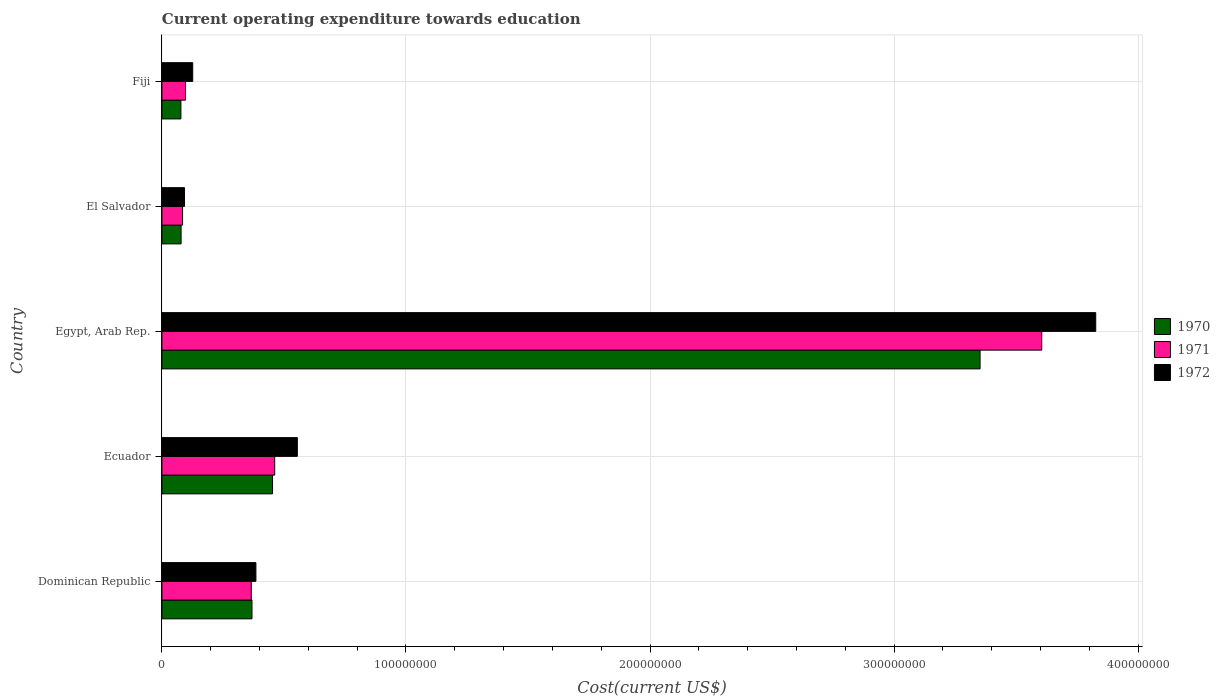What is the label of the 4th group of bars from the top?
Offer a very short reply. Ecuador. What is the expenditure towards education in 1972 in Egypt, Arab Rep.?
Offer a very short reply. 3.83e+08. Across all countries, what is the maximum expenditure towards education in 1970?
Your answer should be very brief. 3.35e+08. Across all countries, what is the minimum expenditure towards education in 1970?
Your response must be concise. 7.79e+06. In which country was the expenditure towards education in 1972 maximum?
Offer a terse response. Egypt, Arab Rep. In which country was the expenditure towards education in 1972 minimum?
Your answer should be very brief. El Salvador. What is the total expenditure towards education in 1971 in the graph?
Provide a short and direct response. 4.61e+08. What is the difference between the expenditure towards education in 1970 in Ecuador and that in Fiji?
Give a very brief answer. 3.75e+07. What is the difference between the expenditure towards education in 1972 in El Salvador and the expenditure towards education in 1971 in Egypt, Arab Rep.?
Your response must be concise. -3.51e+08. What is the average expenditure towards education in 1970 per country?
Provide a succinct answer. 8.66e+07. What is the difference between the expenditure towards education in 1971 and expenditure towards education in 1970 in Dominican Republic?
Provide a short and direct response. -2.90e+05. What is the ratio of the expenditure towards education in 1970 in Egypt, Arab Rep. to that in Fiji?
Offer a terse response. 43.04. Is the difference between the expenditure towards education in 1971 in Ecuador and Fiji greater than the difference between the expenditure towards education in 1970 in Ecuador and Fiji?
Keep it short and to the point. No. What is the difference between the highest and the second highest expenditure towards education in 1972?
Give a very brief answer. 3.27e+08. What is the difference between the highest and the lowest expenditure towards education in 1971?
Provide a succinct answer. 3.52e+08. What does the 2nd bar from the top in Dominican Republic represents?
Give a very brief answer. 1971. What does the 3rd bar from the bottom in El Salvador represents?
Keep it short and to the point. 1972. Is it the case that in every country, the sum of the expenditure towards education in 1971 and expenditure towards education in 1972 is greater than the expenditure towards education in 1970?
Offer a terse response. Yes. Are all the bars in the graph horizontal?
Give a very brief answer. Yes. How many countries are there in the graph?
Offer a very short reply. 5. What is the difference between two consecutive major ticks on the X-axis?
Make the answer very short. 1.00e+08. Does the graph contain any zero values?
Offer a very short reply. No. Where does the legend appear in the graph?
Offer a terse response. Center right. What is the title of the graph?
Provide a succinct answer. Current operating expenditure towards education. What is the label or title of the X-axis?
Ensure brevity in your answer.  Cost(current US$). What is the label or title of the Y-axis?
Provide a short and direct response. Country. What is the Cost(current US$) of 1970 in Dominican Republic?
Ensure brevity in your answer.  3.69e+07. What is the Cost(current US$) in 1971 in Dominican Republic?
Ensure brevity in your answer.  3.66e+07. What is the Cost(current US$) of 1972 in Dominican Republic?
Keep it short and to the point. 3.85e+07. What is the Cost(current US$) in 1970 in Ecuador?
Provide a short and direct response. 4.53e+07. What is the Cost(current US$) in 1971 in Ecuador?
Provide a succinct answer. 4.62e+07. What is the Cost(current US$) in 1972 in Ecuador?
Provide a short and direct response. 5.55e+07. What is the Cost(current US$) of 1970 in Egypt, Arab Rep.?
Offer a very short reply. 3.35e+08. What is the Cost(current US$) in 1971 in Egypt, Arab Rep.?
Offer a very short reply. 3.60e+08. What is the Cost(current US$) in 1972 in Egypt, Arab Rep.?
Your response must be concise. 3.83e+08. What is the Cost(current US$) in 1970 in El Salvador?
Give a very brief answer. 7.86e+06. What is the Cost(current US$) in 1971 in El Salvador?
Ensure brevity in your answer.  8.46e+06. What is the Cost(current US$) in 1972 in El Salvador?
Provide a short and direct response. 9.26e+06. What is the Cost(current US$) of 1970 in Fiji?
Give a very brief answer. 7.79e+06. What is the Cost(current US$) of 1971 in Fiji?
Your response must be concise. 9.67e+06. What is the Cost(current US$) of 1972 in Fiji?
Your answer should be compact. 1.26e+07. Across all countries, what is the maximum Cost(current US$) of 1970?
Keep it short and to the point. 3.35e+08. Across all countries, what is the maximum Cost(current US$) of 1971?
Your answer should be compact. 3.60e+08. Across all countries, what is the maximum Cost(current US$) in 1972?
Offer a very short reply. 3.83e+08. Across all countries, what is the minimum Cost(current US$) of 1970?
Offer a terse response. 7.79e+06. Across all countries, what is the minimum Cost(current US$) in 1971?
Give a very brief answer. 8.46e+06. Across all countries, what is the minimum Cost(current US$) in 1972?
Provide a short and direct response. 9.26e+06. What is the total Cost(current US$) of 1970 in the graph?
Keep it short and to the point. 4.33e+08. What is the total Cost(current US$) of 1971 in the graph?
Offer a terse response. 4.61e+08. What is the total Cost(current US$) in 1972 in the graph?
Your answer should be very brief. 4.98e+08. What is the difference between the Cost(current US$) of 1970 in Dominican Republic and that in Ecuador?
Your answer should be very brief. -8.43e+06. What is the difference between the Cost(current US$) in 1971 in Dominican Republic and that in Ecuador?
Make the answer very short. -9.60e+06. What is the difference between the Cost(current US$) of 1972 in Dominican Republic and that in Ecuador?
Make the answer very short. -1.70e+07. What is the difference between the Cost(current US$) of 1970 in Dominican Republic and that in Egypt, Arab Rep.?
Keep it short and to the point. -2.98e+08. What is the difference between the Cost(current US$) in 1971 in Dominican Republic and that in Egypt, Arab Rep.?
Give a very brief answer. -3.24e+08. What is the difference between the Cost(current US$) of 1972 in Dominican Republic and that in Egypt, Arab Rep.?
Provide a succinct answer. -3.44e+08. What is the difference between the Cost(current US$) of 1970 in Dominican Republic and that in El Salvador?
Offer a very short reply. 2.90e+07. What is the difference between the Cost(current US$) of 1971 in Dominican Republic and that in El Salvador?
Keep it short and to the point. 2.82e+07. What is the difference between the Cost(current US$) of 1972 in Dominican Republic and that in El Salvador?
Give a very brief answer. 2.93e+07. What is the difference between the Cost(current US$) in 1970 in Dominican Republic and that in Fiji?
Provide a short and direct response. 2.91e+07. What is the difference between the Cost(current US$) of 1971 in Dominican Republic and that in Fiji?
Your answer should be compact. 2.69e+07. What is the difference between the Cost(current US$) of 1972 in Dominican Republic and that in Fiji?
Your answer should be compact. 2.59e+07. What is the difference between the Cost(current US$) in 1970 in Ecuador and that in Egypt, Arab Rep.?
Give a very brief answer. -2.90e+08. What is the difference between the Cost(current US$) in 1971 in Ecuador and that in Egypt, Arab Rep.?
Your answer should be very brief. -3.14e+08. What is the difference between the Cost(current US$) of 1972 in Ecuador and that in Egypt, Arab Rep.?
Provide a succinct answer. -3.27e+08. What is the difference between the Cost(current US$) of 1970 in Ecuador and that in El Salvador?
Give a very brief answer. 3.75e+07. What is the difference between the Cost(current US$) in 1971 in Ecuador and that in El Salvador?
Provide a succinct answer. 3.78e+07. What is the difference between the Cost(current US$) in 1972 in Ecuador and that in El Salvador?
Ensure brevity in your answer.  4.62e+07. What is the difference between the Cost(current US$) in 1970 in Ecuador and that in Fiji?
Your response must be concise. 3.75e+07. What is the difference between the Cost(current US$) in 1971 in Ecuador and that in Fiji?
Offer a very short reply. 3.65e+07. What is the difference between the Cost(current US$) of 1972 in Ecuador and that in Fiji?
Your answer should be compact. 4.29e+07. What is the difference between the Cost(current US$) in 1970 in Egypt, Arab Rep. and that in El Salvador?
Your answer should be compact. 3.27e+08. What is the difference between the Cost(current US$) of 1971 in Egypt, Arab Rep. and that in El Salvador?
Make the answer very short. 3.52e+08. What is the difference between the Cost(current US$) in 1972 in Egypt, Arab Rep. and that in El Salvador?
Ensure brevity in your answer.  3.73e+08. What is the difference between the Cost(current US$) of 1970 in Egypt, Arab Rep. and that in Fiji?
Give a very brief answer. 3.27e+08. What is the difference between the Cost(current US$) in 1971 in Egypt, Arab Rep. and that in Fiji?
Your answer should be compact. 3.51e+08. What is the difference between the Cost(current US$) in 1972 in Egypt, Arab Rep. and that in Fiji?
Ensure brevity in your answer.  3.70e+08. What is the difference between the Cost(current US$) in 1970 in El Salvador and that in Fiji?
Make the answer very short. 7.56e+04. What is the difference between the Cost(current US$) of 1971 in El Salvador and that in Fiji?
Provide a short and direct response. -1.21e+06. What is the difference between the Cost(current US$) of 1972 in El Salvador and that in Fiji?
Ensure brevity in your answer.  -3.37e+06. What is the difference between the Cost(current US$) in 1970 in Dominican Republic and the Cost(current US$) in 1971 in Ecuador?
Your answer should be very brief. -9.31e+06. What is the difference between the Cost(current US$) of 1970 in Dominican Republic and the Cost(current US$) of 1972 in Ecuador?
Provide a succinct answer. -1.86e+07. What is the difference between the Cost(current US$) of 1971 in Dominican Republic and the Cost(current US$) of 1972 in Ecuador?
Make the answer very short. -1.89e+07. What is the difference between the Cost(current US$) of 1970 in Dominican Republic and the Cost(current US$) of 1971 in Egypt, Arab Rep.?
Your answer should be compact. -3.24e+08. What is the difference between the Cost(current US$) of 1970 in Dominican Republic and the Cost(current US$) of 1972 in Egypt, Arab Rep.?
Give a very brief answer. -3.46e+08. What is the difference between the Cost(current US$) in 1971 in Dominican Republic and the Cost(current US$) in 1972 in Egypt, Arab Rep.?
Give a very brief answer. -3.46e+08. What is the difference between the Cost(current US$) in 1970 in Dominican Republic and the Cost(current US$) in 1971 in El Salvador?
Offer a terse response. 2.84e+07. What is the difference between the Cost(current US$) in 1970 in Dominican Republic and the Cost(current US$) in 1972 in El Salvador?
Keep it short and to the point. 2.76e+07. What is the difference between the Cost(current US$) in 1971 in Dominican Republic and the Cost(current US$) in 1972 in El Salvador?
Ensure brevity in your answer.  2.74e+07. What is the difference between the Cost(current US$) of 1970 in Dominican Republic and the Cost(current US$) of 1971 in Fiji?
Make the answer very short. 2.72e+07. What is the difference between the Cost(current US$) of 1970 in Dominican Republic and the Cost(current US$) of 1972 in Fiji?
Provide a succinct answer. 2.43e+07. What is the difference between the Cost(current US$) in 1971 in Dominican Republic and the Cost(current US$) in 1972 in Fiji?
Your answer should be compact. 2.40e+07. What is the difference between the Cost(current US$) in 1970 in Ecuador and the Cost(current US$) in 1971 in Egypt, Arab Rep.?
Your answer should be very brief. -3.15e+08. What is the difference between the Cost(current US$) in 1970 in Ecuador and the Cost(current US$) in 1972 in Egypt, Arab Rep.?
Your answer should be very brief. -3.37e+08. What is the difference between the Cost(current US$) of 1971 in Ecuador and the Cost(current US$) of 1972 in Egypt, Arab Rep.?
Offer a very short reply. -3.36e+08. What is the difference between the Cost(current US$) of 1970 in Ecuador and the Cost(current US$) of 1971 in El Salvador?
Offer a terse response. 3.69e+07. What is the difference between the Cost(current US$) in 1970 in Ecuador and the Cost(current US$) in 1972 in El Salvador?
Offer a terse response. 3.61e+07. What is the difference between the Cost(current US$) of 1971 in Ecuador and the Cost(current US$) of 1972 in El Salvador?
Your response must be concise. 3.70e+07. What is the difference between the Cost(current US$) of 1970 in Ecuador and the Cost(current US$) of 1971 in Fiji?
Provide a short and direct response. 3.57e+07. What is the difference between the Cost(current US$) of 1970 in Ecuador and the Cost(current US$) of 1972 in Fiji?
Your response must be concise. 3.27e+07. What is the difference between the Cost(current US$) of 1971 in Ecuador and the Cost(current US$) of 1972 in Fiji?
Keep it short and to the point. 3.36e+07. What is the difference between the Cost(current US$) of 1970 in Egypt, Arab Rep. and the Cost(current US$) of 1971 in El Salvador?
Your response must be concise. 3.27e+08. What is the difference between the Cost(current US$) in 1970 in Egypt, Arab Rep. and the Cost(current US$) in 1972 in El Salvador?
Offer a very short reply. 3.26e+08. What is the difference between the Cost(current US$) of 1971 in Egypt, Arab Rep. and the Cost(current US$) of 1972 in El Salvador?
Provide a succinct answer. 3.51e+08. What is the difference between the Cost(current US$) of 1970 in Egypt, Arab Rep. and the Cost(current US$) of 1971 in Fiji?
Your response must be concise. 3.26e+08. What is the difference between the Cost(current US$) in 1970 in Egypt, Arab Rep. and the Cost(current US$) in 1972 in Fiji?
Give a very brief answer. 3.23e+08. What is the difference between the Cost(current US$) of 1971 in Egypt, Arab Rep. and the Cost(current US$) of 1972 in Fiji?
Your answer should be very brief. 3.48e+08. What is the difference between the Cost(current US$) of 1970 in El Salvador and the Cost(current US$) of 1971 in Fiji?
Your answer should be very brief. -1.81e+06. What is the difference between the Cost(current US$) of 1970 in El Salvador and the Cost(current US$) of 1972 in Fiji?
Provide a short and direct response. -4.76e+06. What is the difference between the Cost(current US$) in 1971 in El Salvador and the Cost(current US$) in 1972 in Fiji?
Provide a short and direct response. -4.16e+06. What is the average Cost(current US$) of 1970 per country?
Make the answer very short. 8.66e+07. What is the average Cost(current US$) of 1971 per country?
Provide a succinct answer. 9.23e+07. What is the average Cost(current US$) of 1972 per country?
Offer a terse response. 9.97e+07. What is the difference between the Cost(current US$) in 1970 and Cost(current US$) in 1971 in Dominican Republic?
Make the answer very short. 2.90e+05. What is the difference between the Cost(current US$) in 1970 and Cost(current US$) in 1972 in Dominican Republic?
Make the answer very short. -1.61e+06. What is the difference between the Cost(current US$) in 1971 and Cost(current US$) in 1972 in Dominican Republic?
Provide a short and direct response. -1.90e+06. What is the difference between the Cost(current US$) of 1970 and Cost(current US$) of 1971 in Ecuador?
Provide a short and direct response. -8.82e+05. What is the difference between the Cost(current US$) of 1970 and Cost(current US$) of 1972 in Ecuador?
Provide a succinct answer. -1.02e+07. What is the difference between the Cost(current US$) in 1971 and Cost(current US$) in 1972 in Ecuador?
Make the answer very short. -9.27e+06. What is the difference between the Cost(current US$) of 1970 and Cost(current US$) of 1971 in Egypt, Arab Rep.?
Keep it short and to the point. -2.53e+07. What is the difference between the Cost(current US$) of 1970 and Cost(current US$) of 1972 in Egypt, Arab Rep.?
Keep it short and to the point. -4.74e+07. What is the difference between the Cost(current US$) in 1971 and Cost(current US$) in 1972 in Egypt, Arab Rep.?
Ensure brevity in your answer.  -2.21e+07. What is the difference between the Cost(current US$) in 1970 and Cost(current US$) in 1971 in El Salvador?
Keep it short and to the point. -6.00e+05. What is the difference between the Cost(current US$) of 1970 and Cost(current US$) of 1972 in El Salvador?
Keep it short and to the point. -1.39e+06. What is the difference between the Cost(current US$) of 1971 and Cost(current US$) of 1972 in El Salvador?
Your answer should be very brief. -7.94e+05. What is the difference between the Cost(current US$) of 1970 and Cost(current US$) of 1971 in Fiji?
Your answer should be compact. -1.89e+06. What is the difference between the Cost(current US$) of 1970 and Cost(current US$) of 1972 in Fiji?
Your answer should be compact. -4.84e+06. What is the difference between the Cost(current US$) in 1971 and Cost(current US$) in 1972 in Fiji?
Provide a short and direct response. -2.95e+06. What is the ratio of the Cost(current US$) in 1970 in Dominican Republic to that in Ecuador?
Offer a terse response. 0.81. What is the ratio of the Cost(current US$) in 1971 in Dominican Republic to that in Ecuador?
Ensure brevity in your answer.  0.79. What is the ratio of the Cost(current US$) in 1972 in Dominican Republic to that in Ecuador?
Offer a very short reply. 0.69. What is the ratio of the Cost(current US$) in 1970 in Dominican Republic to that in Egypt, Arab Rep.?
Provide a succinct answer. 0.11. What is the ratio of the Cost(current US$) of 1971 in Dominican Republic to that in Egypt, Arab Rep.?
Ensure brevity in your answer.  0.1. What is the ratio of the Cost(current US$) of 1972 in Dominican Republic to that in Egypt, Arab Rep.?
Offer a very short reply. 0.1. What is the ratio of the Cost(current US$) in 1970 in Dominican Republic to that in El Salvador?
Provide a succinct answer. 4.69. What is the ratio of the Cost(current US$) in 1971 in Dominican Republic to that in El Salvador?
Make the answer very short. 4.33. What is the ratio of the Cost(current US$) of 1972 in Dominican Republic to that in El Salvador?
Your answer should be very brief. 4.16. What is the ratio of the Cost(current US$) of 1970 in Dominican Republic to that in Fiji?
Your response must be concise. 4.74. What is the ratio of the Cost(current US$) of 1971 in Dominican Republic to that in Fiji?
Your answer should be compact. 3.79. What is the ratio of the Cost(current US$) in 1972 in Dominican Republic to that in Fiji?
Your answer should be compact. 3.05. What is the ratio of the Cost(current US$) of 1970 in Ecuador to that in Egypt, Arab Rep.?
Your answer should be very brief. 0.14. What is the ratio of the Cost(current US$) in 1971 in Ecuador to that in Egypt, Arab Rep.?
Your response must be concise. 0.13. What is the ratio of the Cost(current US$) in 1972 in Ecuador to that in Egypt, Arab Rep.?
Offer a very short reply. 0.14. What is the ratio of the Cost(current US$) of 1970 in Ecuador to that in El Salvador?
Your answer should be very brief. 5.77. What is the ratio of the Cost(current US$) in 1971 in Ecuador to that in El Salvador?
Your answer should be very brief. 5.46. What is the ratio of the Cost(current US$) of 1972 in Ecuador to that in El Salvador?
Your response must be concise. 5.99. What is the ratio of the Cost(current US$) of 1970 in Ecuador to that in Fiji?
Offer a very short reply. 5.82. What is the ratio of the Cost(current US$) in 1971 in Ecuador to that in Fiji?
Offer a very short reply. 4.78. What is the ratio of the Cost(current US$) in 1972 in Ecuador to that in Fiji?
Your answer should be very brief. 4.39. What is the ratio of the Cost(current US$) of 1970 in Egypt, Arab Rep. to that in El Salvador?
Ensure brevity in your answer.  42.63. What is the ratio of the Cost(current US$) in 1971 in Egypt, Arab Rep. to that in El Salvador?
Provide a short and direct response. 42.59. What is the ratio of the Cost(current US$) of 1972 in Egypt, Arab Rep. to that in El Salvador?
Make the answer very short. 41.33. What is the ratio of the Cost(current US$) in 1970 in Egypt, Arab Rep. to that in Fiji?
Your answer should be compact. 43.04. What is the ratio of the Cost(current US$) of 1971 in Egypt, Arab Rep. to that in Fiji?
Give a very brief answer. 37.26. What is the ratio of the Cost(current US$) in 1972 in Egypt, Arab Rep. to that in Fiji?
Offer a very short reply. 30.3. What is the ratio of the Cost(current US$) of 1970 in El Salvador to that in Fiji?
Offer a very short reply. 1.01. What is the ratio of the Cost(current US$) of 1971 in El Salvador to that in Fiji?
Offer a very short reply. 0.87. What is the ratio of the Cost(current US$) in 1972 in El Salvador to that in Fiji?
Make the answer very short. 0.73. What is the difference between the highest and the second highest Cost(current US$) in 1970?
Your response must be concise. 2.90e+08. What is the difference between the highest and the second highest Cost(current US$) of 1971?
Your answer should be very brief. 3.14e+08. What is the difference between the highest and the second highest Cost(current US$) in 1972?
Give a very brief answer. 3.27e+08. What is the difference between the highest and the lowest Cost(current US$) in 1970?
Provide a short and direct response. 3.27e+08. What is the difference between the highest and the lowest Cost(current US$) of 1971?
Your response must be concise. 3.52e+08. What is the difference between the highest and the lowest Cost(current US$) of 1972?
Keep it short and to the point. 3.73e+08. 